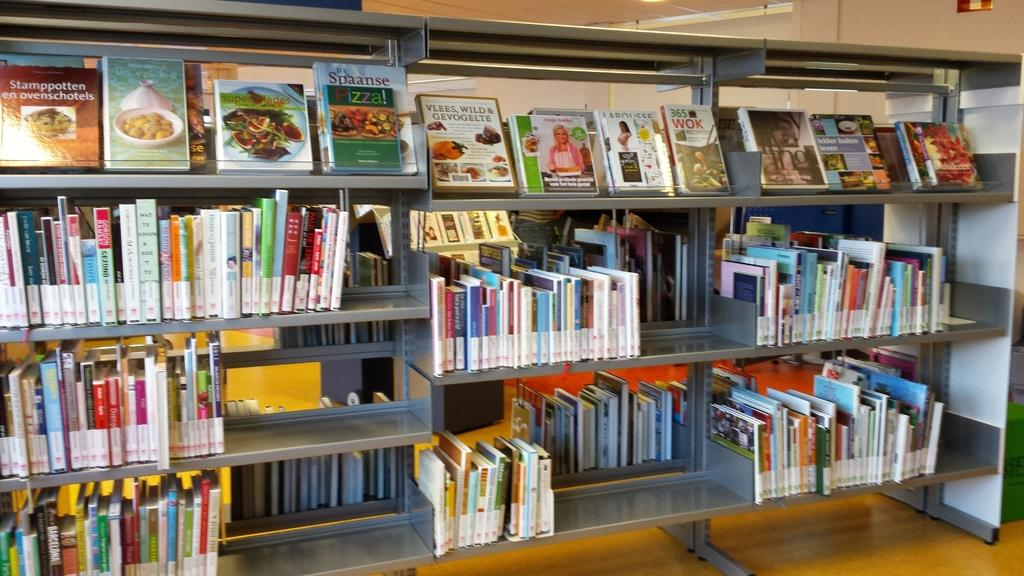<image>
Offer a succinct explanation of the picture presented. a book rack with three separate rows of different books including cook books at the top. 